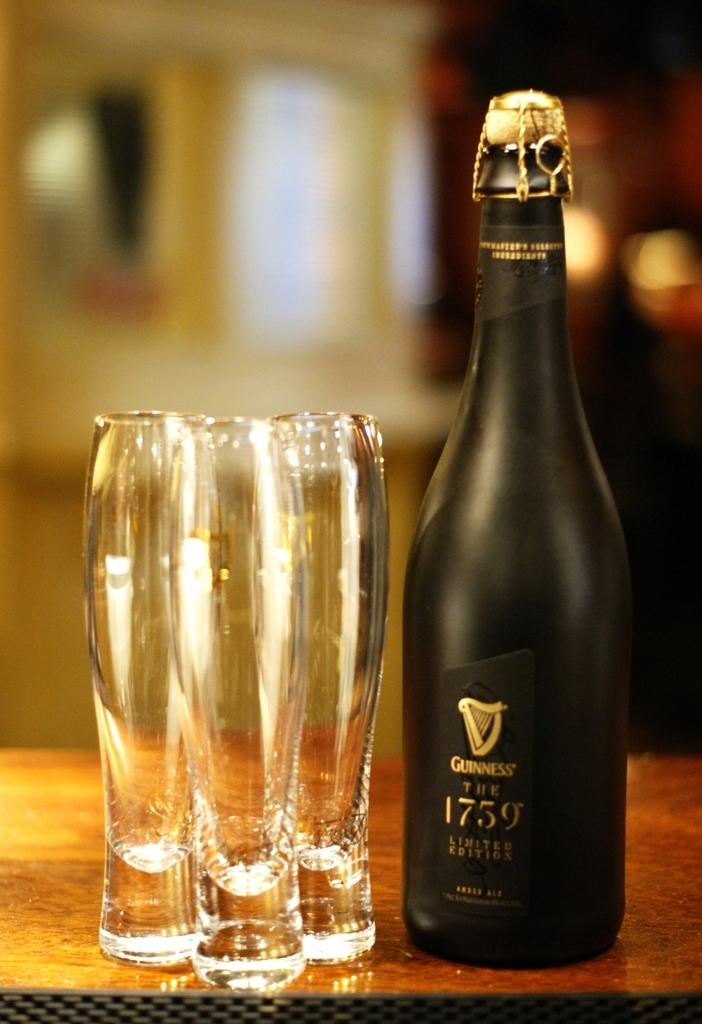<image>
Give a short and clear explanation of the subsequent image. A limited edition bottle of Guinness is on a table with 3 small glasses. 